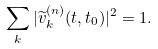Convert formula to latex. <formula><loc_0><loc_0><loc_500><loc_500>\sum _ { k } | \widetilde { v } ^ { ( n ) } _ { k } ( t , t _ { 0 } ) | ^ { 2 } = 1 .</formula> 